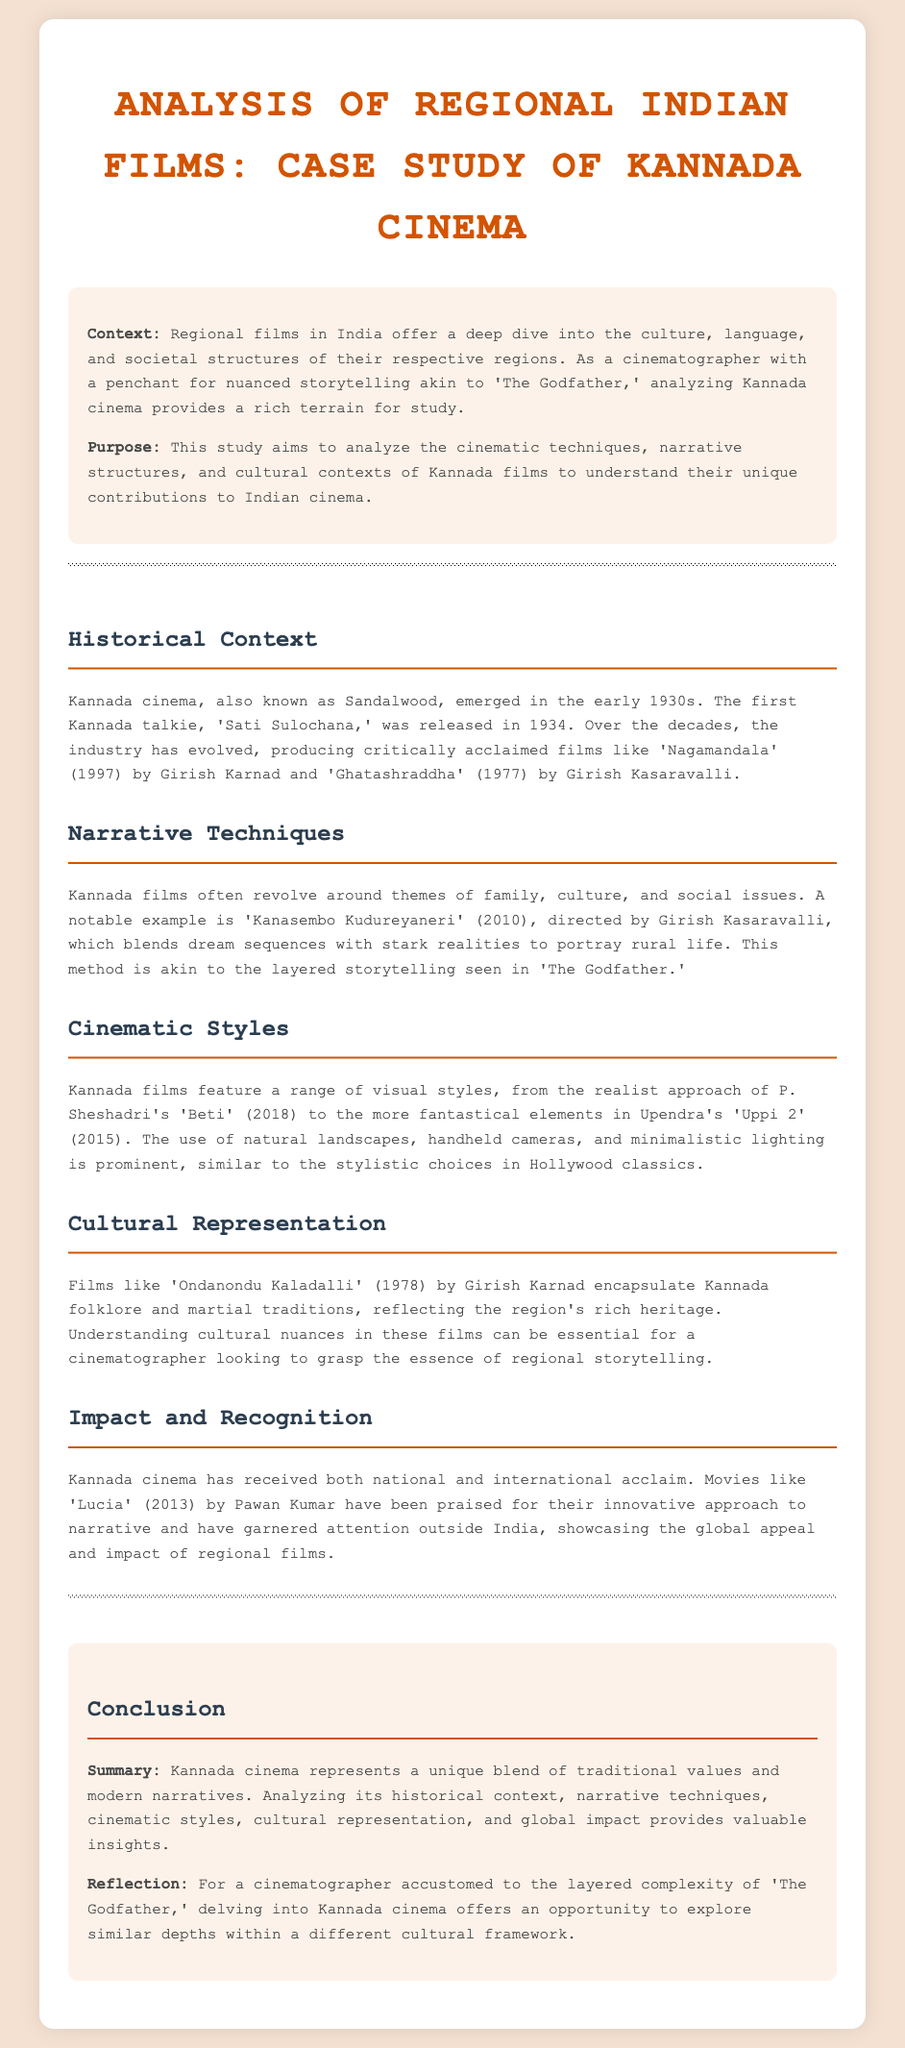What is the first Kannada talkie film? The document mentions that the first Kannada talkie film is 'Sati Sulochana,' released in 1934.
Answer: 'Sati Sulochana' Who directed 'Kanasembo Kudureyaneri'? The document states that 'Kanasembo Kudureyaneri' was directed by Girish Kasaravalli.
Answer: Girish Kasaravalli What year was 'Lucia' released? The document indicates that 'Lucia' was released in 2013.
Answer: 2013 What is the primary theme of many Kannada films? The document highlights that Kannada films often revolve around themes of family, culture, and social issues.
Answer: Family, culture, and social issues Which film is cited as an example of a realist approach in Kannada cinema? According to the document, P. Sheshadri's film 'Beti' (2018) is an example of a realist approach.
Answer: 'Beti' What unique narrative technique does 'Kanasembo Kudureyaneri' use? The document describes that 'Kanasembo Kudureyaneri' blends dream sequences with stark realities.
Answer: Blends dream sequences with stark realities Which filmmaker is associated with 'Ondanondu Kaladalli'? The document mentions that 'Ondanondu Kaladalli' was made by Girish Karnad.
Answer: Girish Karnad What is the aim of this study on Kannada cinema? The document states that the study aims to analyze the cinematic techniques, narrative structures, and cultural contexts of Kannada films.
Answer: Analyze cinematic techniques, narrative structures, and cultural contexts What is the global recognition of Kannada cinema illustrated by? The document illustrates the global recognition of Kannada cinema through the film 'Lucia.'
Answer: 'Lucia' 